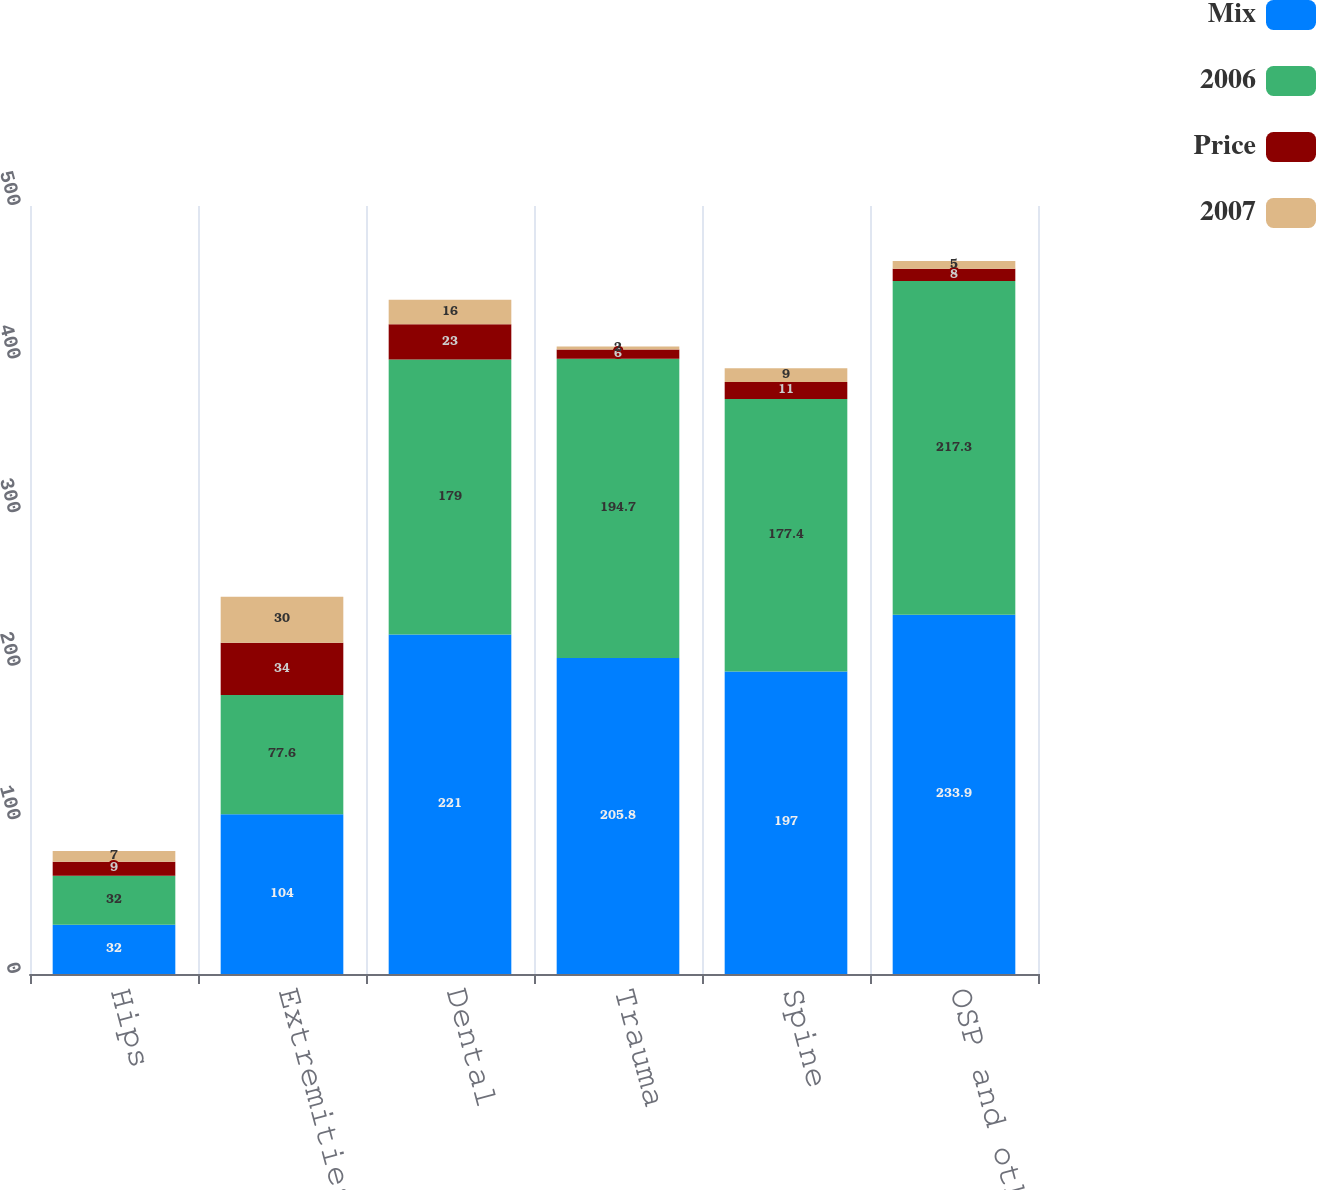<chart> <loc_0><loc_0><loc_500><loc_500><stacked_bar_chart><ecel><fcel>Hips<fcel>Extremities<fcel>Dental<fcel>Trauma<fcel>Spine<fcel>OSP and other<nl><fcel>Mix<fcel>32<fcel>104<fcel>221<fcel>205.8<fcel>197<fcel>233.9<nl><fcel>2006<fcel>32<fcel>77.6<fcel>179<fcel>194.7<fcel>177.4<fcel>217.3<nl><fcel>Price<fcel>9<fcel>34<fcel>23<fcel>6<fcel>11<fcel>8<nl><fcel>2007<fcel>7<fcel>30<fcel>16<fcel>2<fcel>9<fcel>5<nl></chart> 